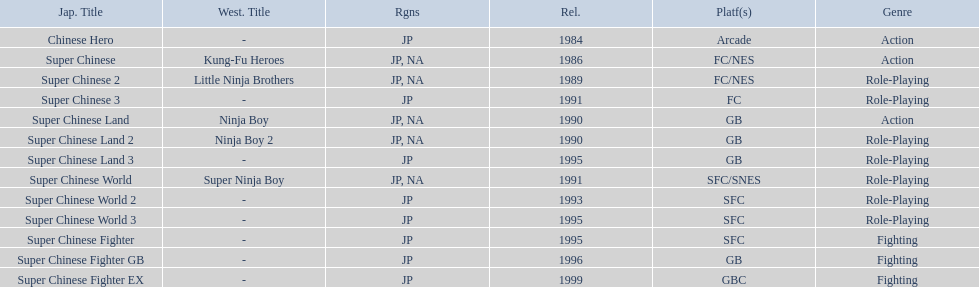Which titles were released in north america? Super Chinese, Super Chinese 2, Super Chinese Land, Super Chinese Land 2, Super Chinese World. Of those, which had the least releases? Super Chinese World. 